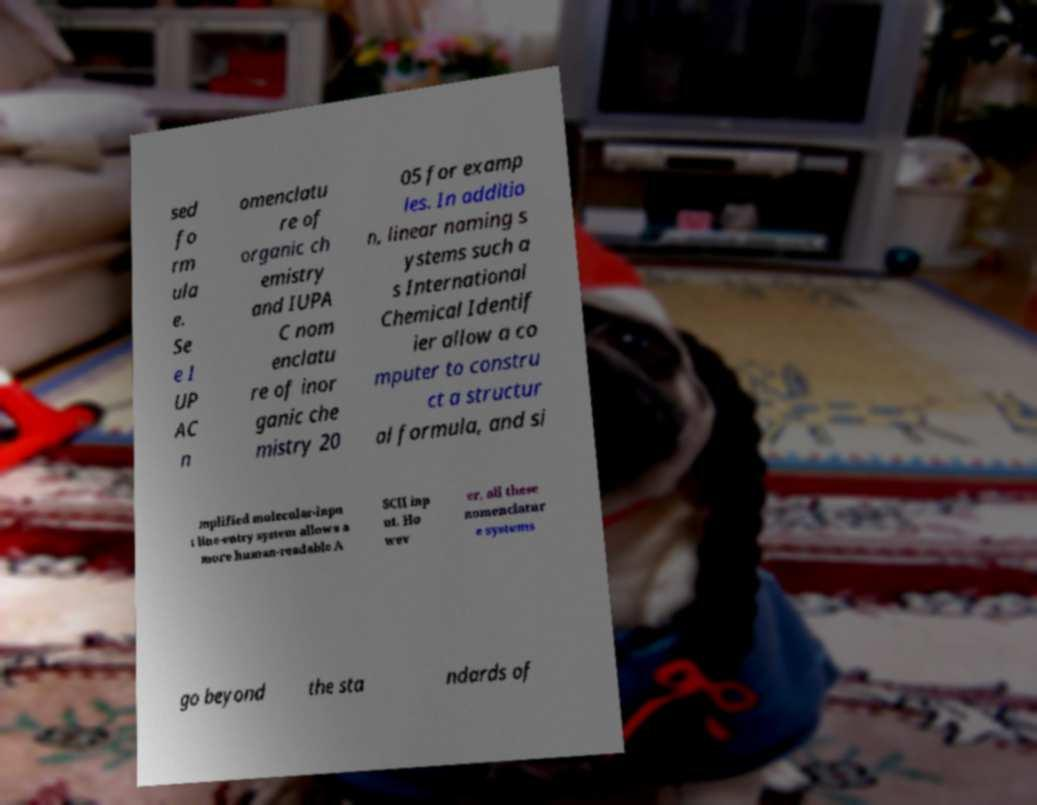Please identify and transcribe the text found in this image. sed fo rm ula e. Se e I UP AC n omenclatu re of organic ch emistry and IUPA C nom enclatu re of inor ganic che mistry 20 05 for examp les. In additio n, linear naming s ystems such a s International Chemical Identif ier allow a co mputer to constru ct a structur al formula, and si mplified molecular-inpu t line-entry system allows a more human-readable A SCII inp ut. Ho wev er, all these nomenclatur e systems go beyond the sta ndards of 